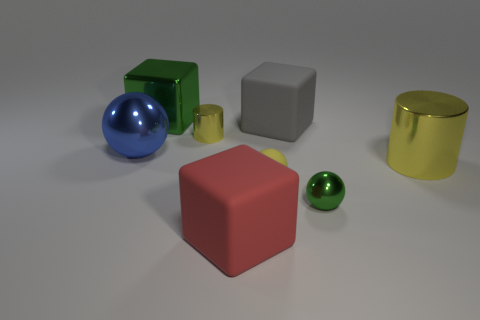Add 2 tiny yellow cylinders. How many objects exist? 10 Subtract all cubes. How many objects are left? 5 Add 4 big gray matte cubes. How many big gray matte cubes are left? 5 Add 2 small cyan matte cylinders. How many small cyan matte cylinders exist? 2 Subtract 2 yellow cylinders. How many objects are left? 6 Subtract all blue metallic spheres. Subtract all big blue metal balls. How many objects are left? 6 